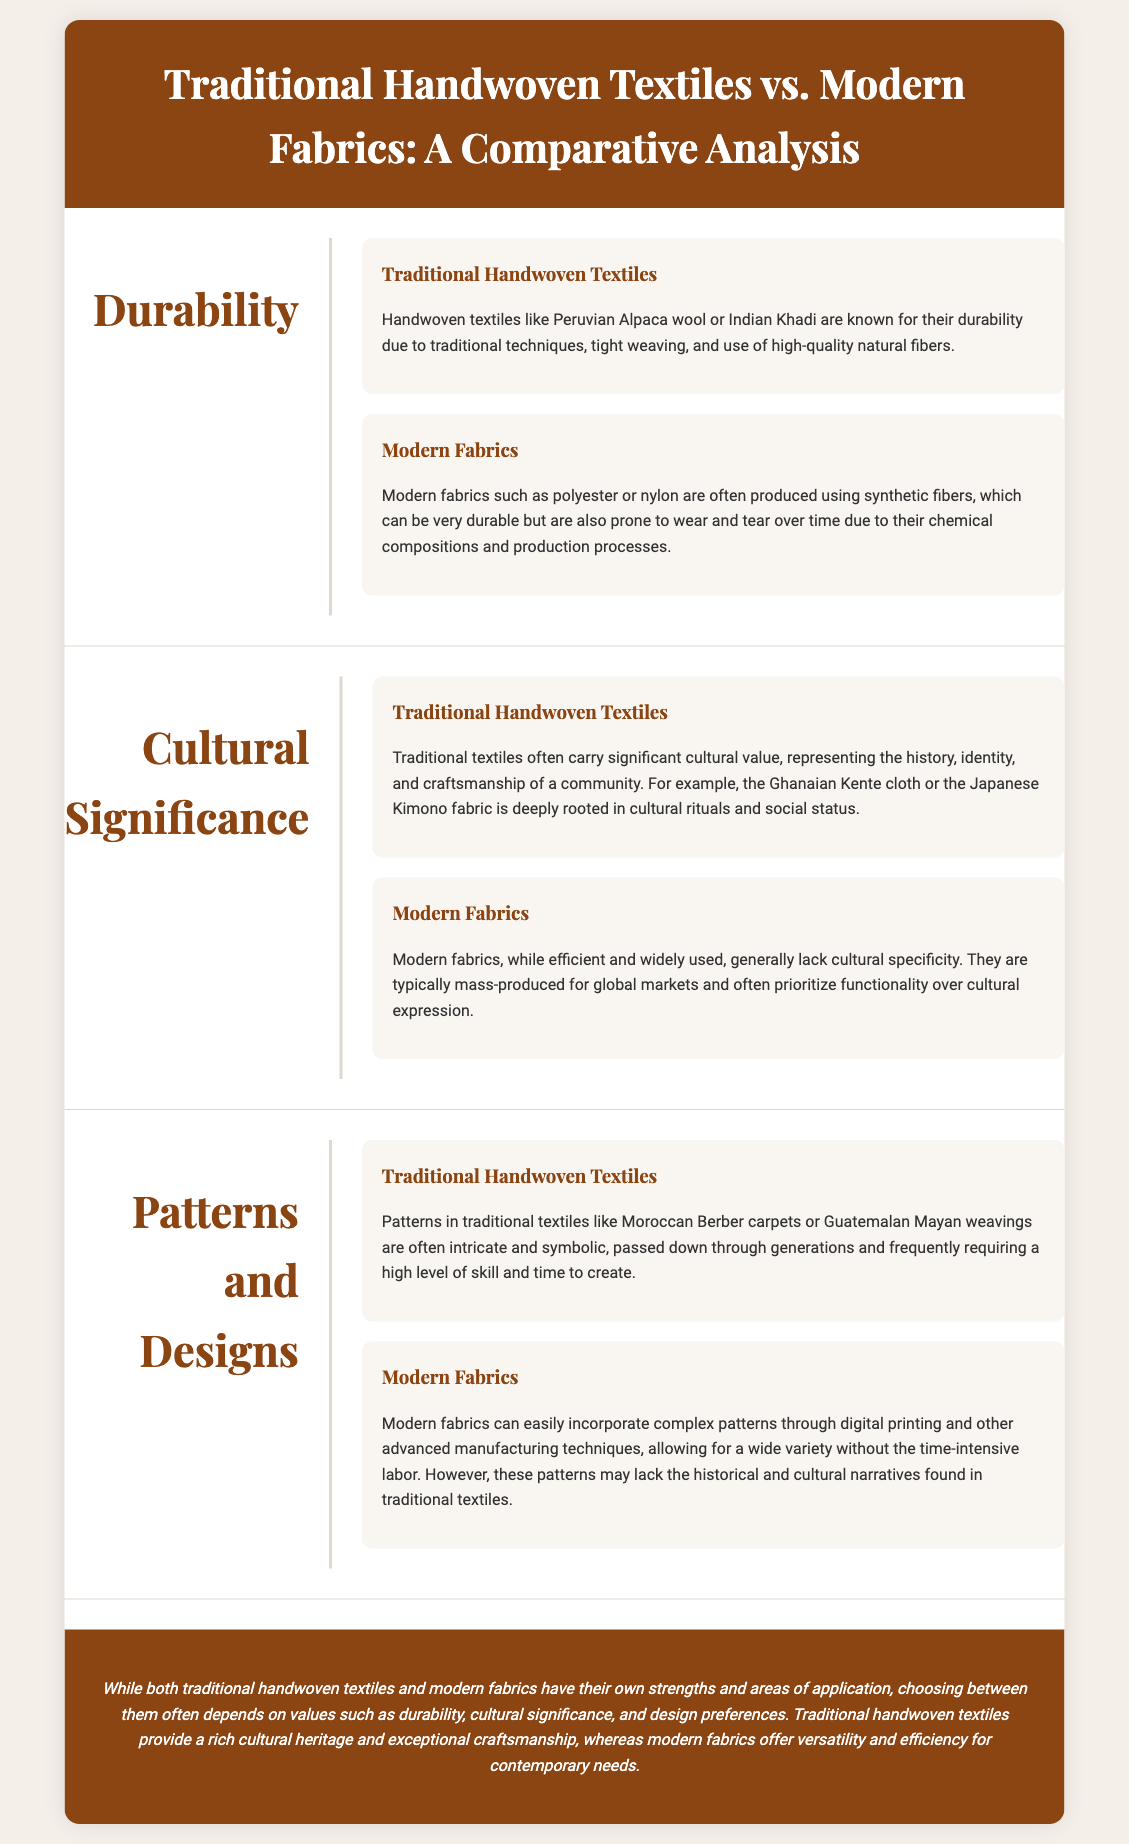what is the title of the document? The title of the document is presented in the header section and clearly states the topic being discussed.
Answer: Traditional Handwoven Textiles vs. Modern Fabrics: A Comparative Analysis which traditional fabric is mentioned for its durability? The document specifies Peruvian Alpaca wool in the context of durability of traditional textiles.
Answer: Peruvian Alpaca wool what is a common pattern feature of modern fabrics? The document notes that modern fabrics can incorporate complex patterns through digital printing and advanced manufacturing techniques.
Answer: Complex patterns what significant cultural textile is highlighted from Ghana? The document mentions the Ghanaian Kente cloth as an example of significant cultural value in traditional textiles.
Answer: Kente cloth which fabric type is often mass-produced for global markets? The document indicates that modern fabrics are typically mass-produced for global markets, lacking cultural specificity.
Answer: Modern fabrics how are patterns in traditional handwoven textiles often characterized? The document describes patterns in traditional textiles as intricate and symbolic, often passed down through generations.
Answer: Intricate and symbolic what is stated about the durability of modern fabrics? The document explains that modern fabrics, made from synthetic fibers, can be very durable but may suffer from wear and tear over time.
Answer: Can be very durable which fabric type prioritizes cultural expression? According to the document, traditional handwoven textiles prioritize cultural expression over mass production.
Answer: Traditional handwoven textiles 